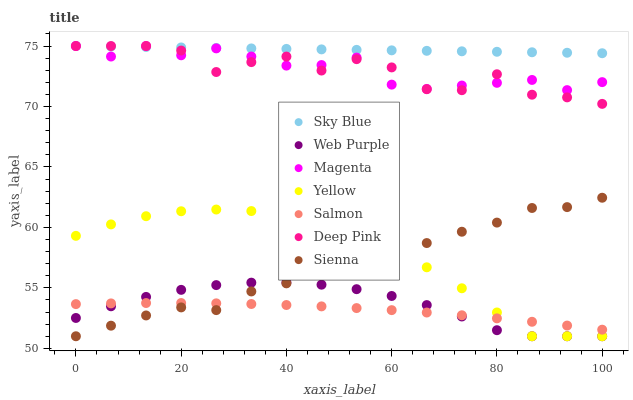Does Salmon have the minimum area under the curve?
Answer yes or no. Yes. Does Sky Blue have the maximum area under the curve?
Answer yes or no. Yes. Does Yellow have the minimum area under the curve?
Answer yes or no. No. Does Yellow have the maximum area under the curve?
Answer yes or no. No. Is Sky Blue the smoothest?
Answer yes or no. Yes. Is Deep Pink the roughest?
Answer yes or no. Yes. Is Salmon the smoothest?
Answer yes or no. No. Is Salmon the roughest?
Answer yes or no. No. Does Yellow have the lowest value?
Answer yes or no. Yes. Does Salmon have the lowest value?
Answer yes or no. No. Does Magenta have the highest value?
Answer yes or no. Yes. Does Yellow have the highest value?
Answer yes or no. No. Is Salmon less than Deep Pink?
Answer yes or no. Yes. Is Magenta greater than Salmon?
Answer yes or no. Yes. Does Sky Blue intersect Deep Pink?
Answer yes or no. Yes. Is Sky Blue less than Deep Pink?
Answer yes or no. No. Is Sky Blue greater than Deep Pink?
Answer yes or no. No. Does Salmon intersect Deep Pink?
Answer yes or no. No. 